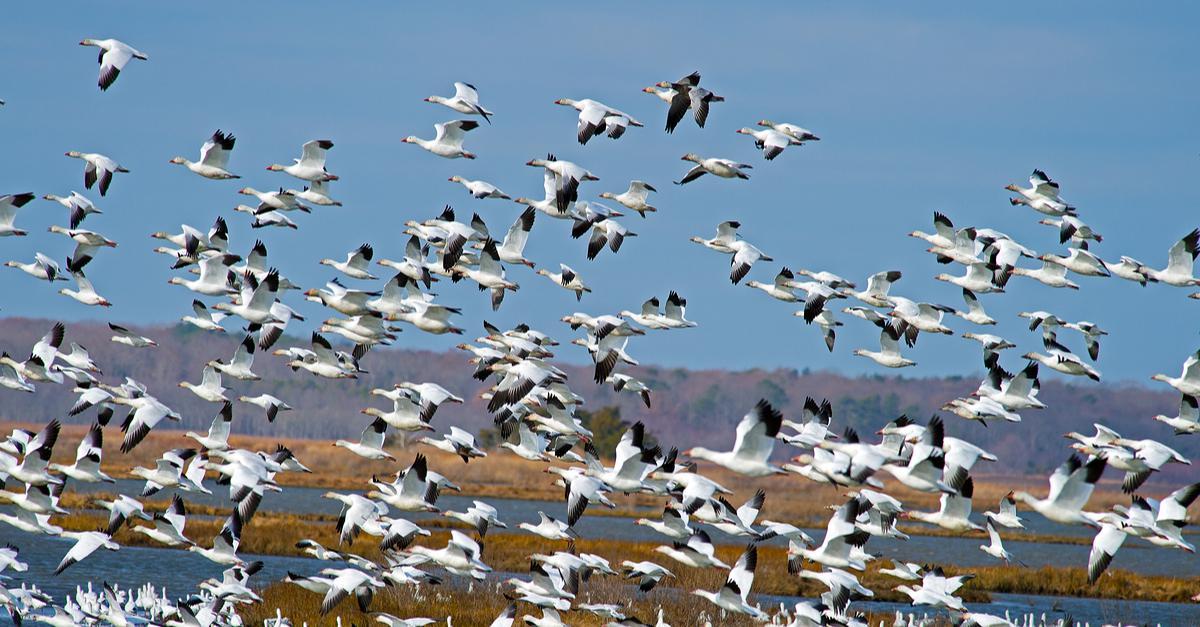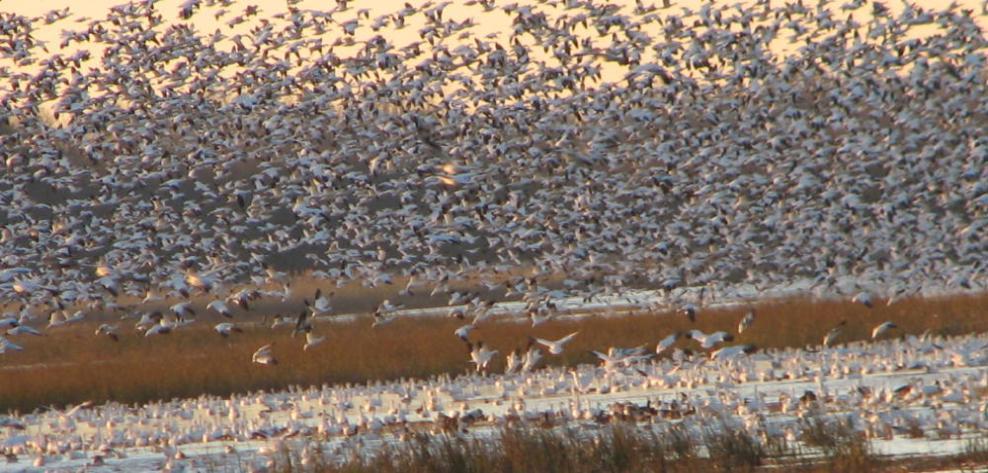The first image is the image on the left, the second image is the image on the right. Evaluate the accuracy of this statement regarding the images: "All of the birds are in the water in the image on the right.". Is it true? Answer yes or no. No. 